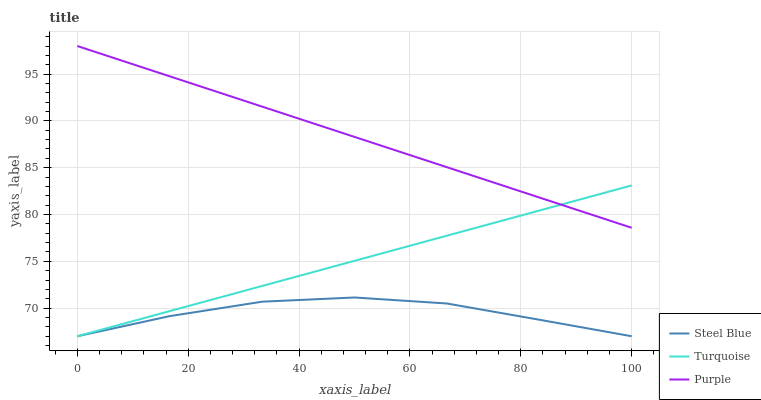Does Turquoise have the minimum area under the curve?
Answer yes or no. No. Does Turquoise have the maximum area under the curve?
Answer yes or no. No. Is Steel Blue the smoothest?
Answer yes or no. No. Is Turquoise the roughest?
Answer yes or no. No. Does Turquoise have the highest value?
Answer yes or no. No. Is Steel Blue less than Purple?
Answer yes or no. Yes. Is Purple greater than Steel Blue?
Answer yes or no. Yes. Does Steel Blue intersect Purple?
Answer yes or no. No. 